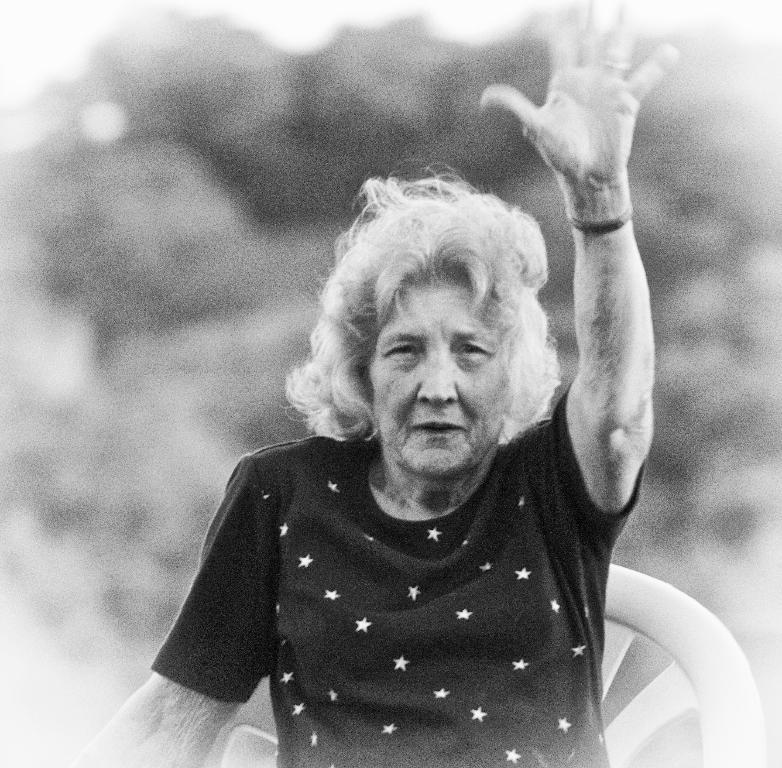What is the color scheme of the image? The image is black and white. Who is present in the image? There is a woman in the image. What is the woman doing in the image? The woman is sitting on a chair. Can you describe the background of the image? The background of the image is blurred. Where is the rabbit hiding in the image? There is no rabbit present in the image. What type of bone can be seen in the woman's hand in the image? There is no bone visible in the woman's hand or anywhere else in the image. 